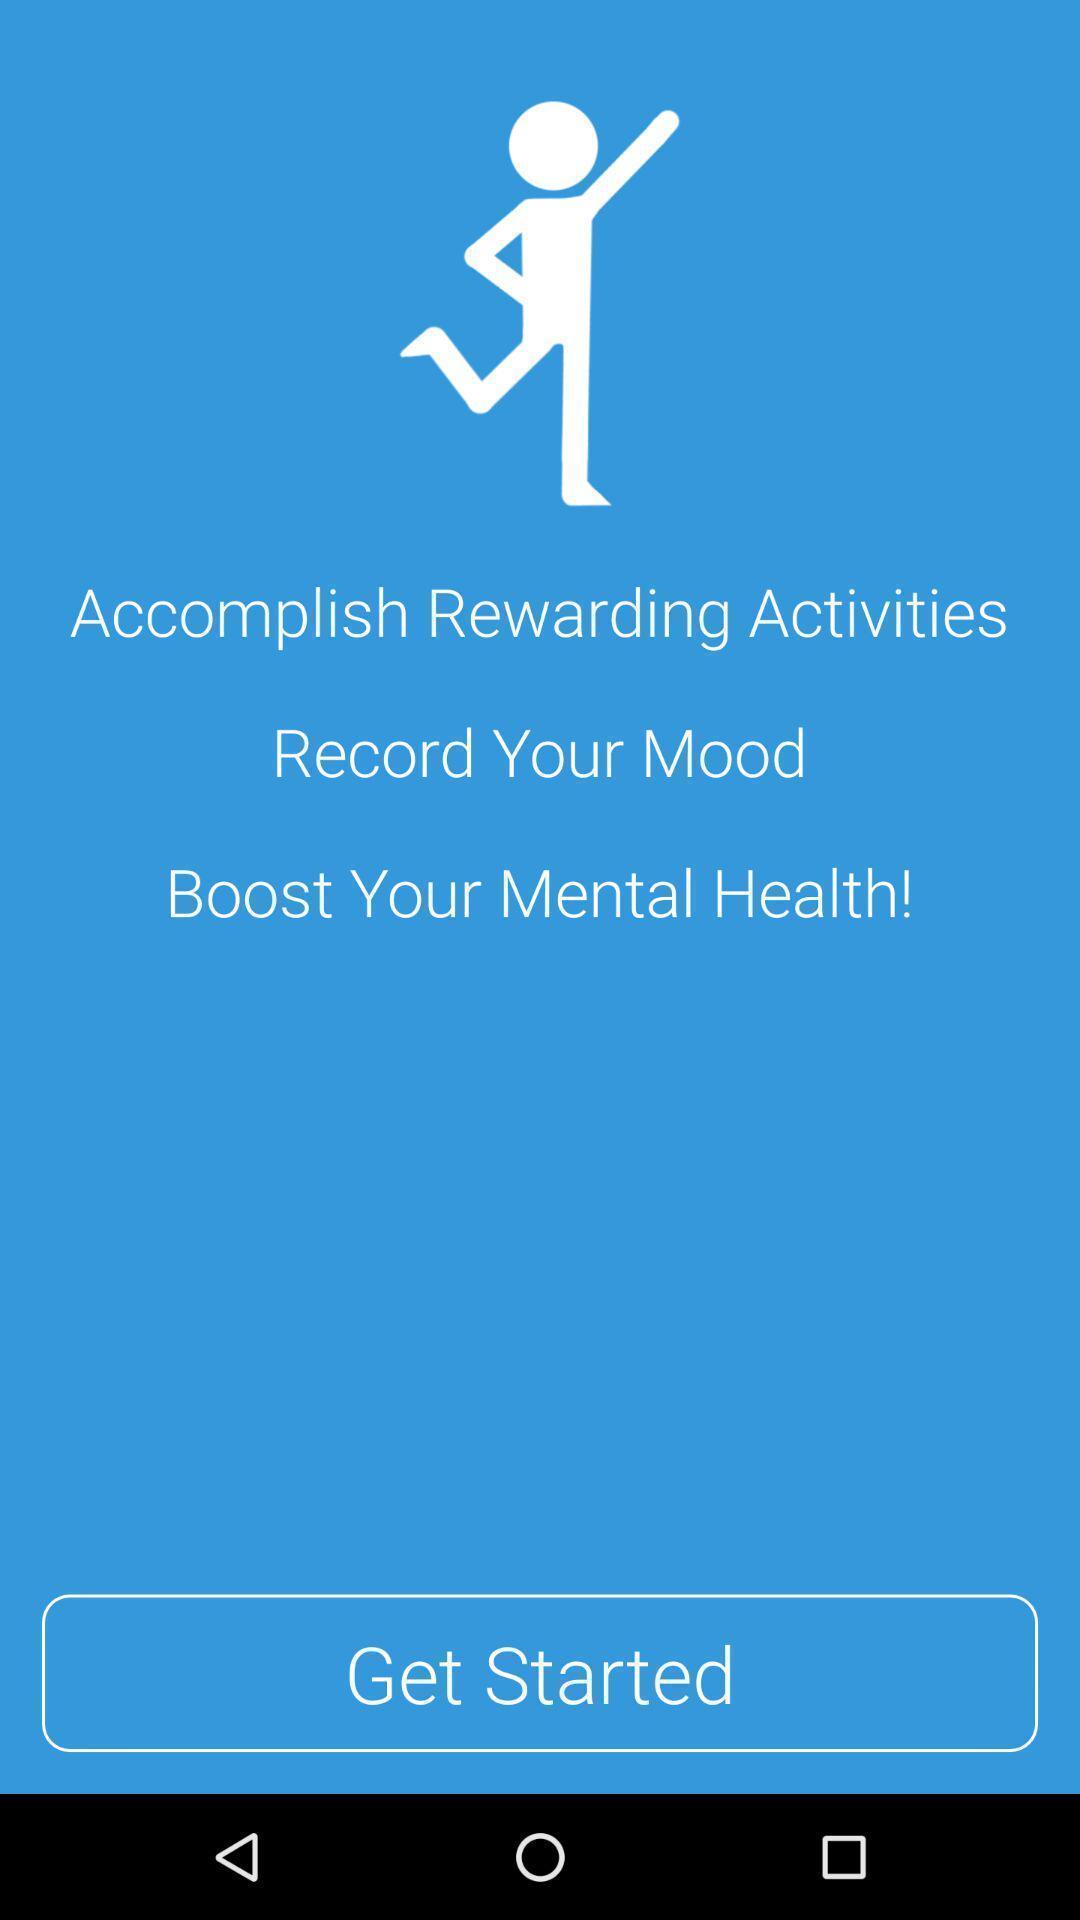What is the overall content of this screenshot? Welcome page for a mental health tracking app. 